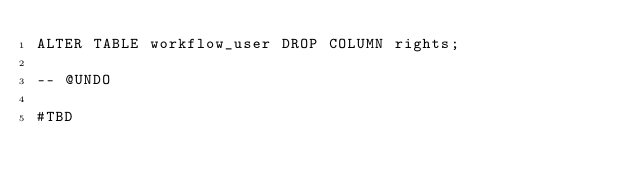Convert code to text. <code><loc_0><loc_0><loc_500><loc_500><_SQL_>ALTER TABLE workflow_user DROP COLUMN rights;

-- @UNDO

#TBD</code> 